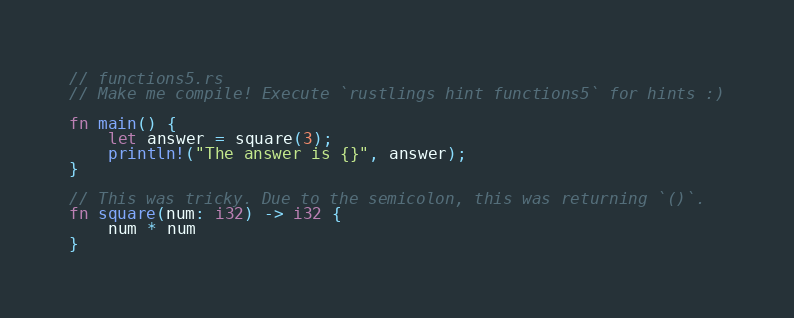Convert code to text. <code><loc_0><loc_0><loc_500><loc_500><_Rust_>// functions5.rs
// Make me compile! Execute `rustlings hint functions5` for hints :)

fn main() {
    let answer = square(3);
    println!("The answer is {}", answer);
}

// This was tricky. Due to the semicolon, this was returning `()`.
fn square(num: i32) -> i32 {
    num * num
}
</code> 